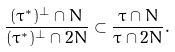Convert formula to latex. <formula><loc_0><loc_0><loc_500><loc_500>\frac { ( \tau ^ { * } ) ^ { \perp } \cap N } { ( \tau ^ { * } ) ^ { \perp } \cap 2 N } \subset \frac { \tau \cap N } { \tau \cap 2 N } .</formula> 